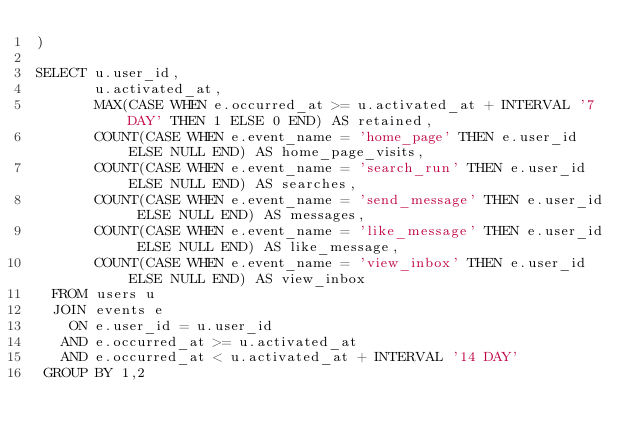<code> <loc_0><loc_0><loc_500><loc_500><_SQL_>)

SELECT u.user_id,
       u.activated_at,
       MAX(CASE WHEN e.occurred_at >= u.activated_at + INTERVAL '7 DAY' THEN 1 ELSE 0 END) AS retained,
       COUNT(CASE WHEN e.event_name = 'home_page' THEN e.user_id ELSE NULL END) AS home_page_visits,
       COUNT(CASE WHEN e.event_name = 'search_run' THEN e.user_id ELSE NULL END) AS searches,
       COUNT(CASE WHEN e.event_name = 'send_message' THEN e.user_id ELSE NULL END) AS messages,
       COUNT(CASE WHEN e.event_name = 'like_message' THEN e.user_id ELSE NULL END) AS like_message,
       COUNT(CASE WHEN e.event_name = 'view_inbox' THEN e.user_id ELSE NULL END) AS view_inbox
  FROM users u
  JOIN events e
    ON e.user_id = u.user_id
   AND e.occurred_at >= u.activated_at
   AND e.occurred_at < u.activated_at + INTERVAL '14 DAY'
 GROUP BY 1,2</code> 